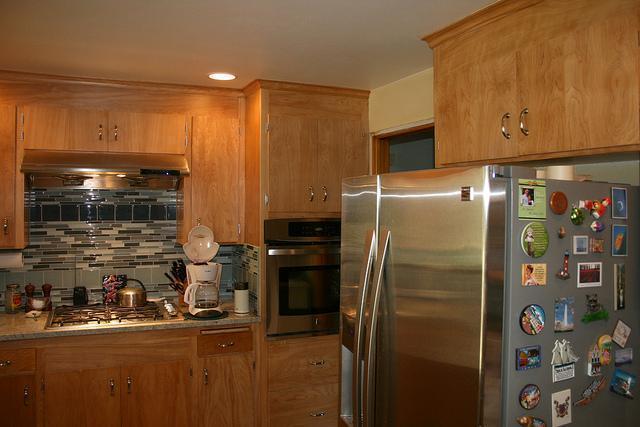How many ovens are visible?
Give a very brief answer. 1. 